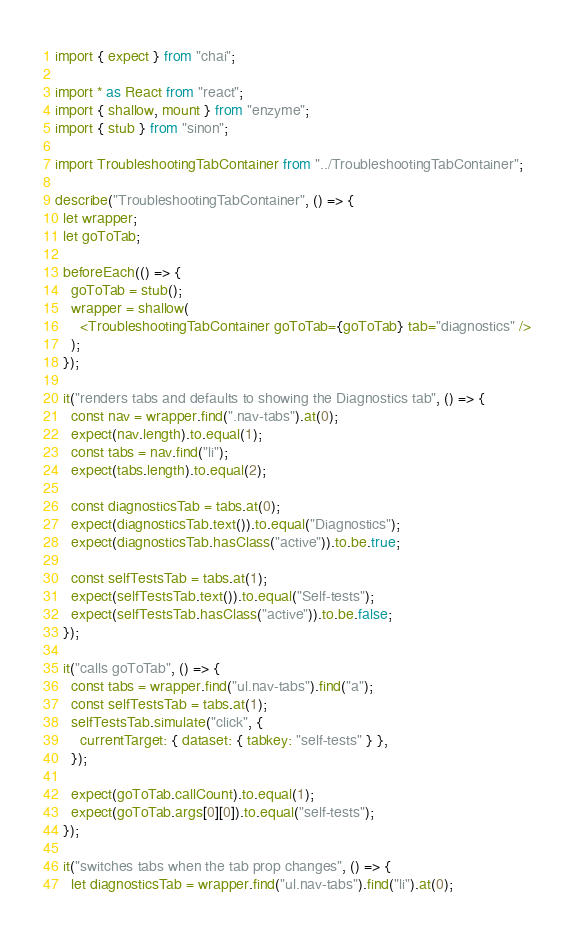<code> <loc_0><loc_0><loc_500><loc_500><_TypeScript_>import { expect } from "chai";

import * as React from "react";
import { shallow, mount } from "enzyme";
import { stub } from "sinon";

import TroubleshootingTabContainer from "../TroubleshootingTabContainer";

describe("TroubleshootingTabContainer", () => {
  let wrapper;
  let goToTab;

  beforeEach(() => {
    goToTab = stub();
    wrapper = shallow(
      <TroubleshootingTabContainer goToTab={goToTab} tab="diagnostics" />
    );
  });

  it("renders tabs and defaults to showing the Diagnostics tab", () => {
    const nav = wrapper.find(".nav-tabs").at(0);
    expect(nav.length).to.equal(1);
    const tabs = nav.find("li");
    expect(tabs.length).to.equal(2);

    const diagnosticsTab = tabs.at(0);
    expect(diagnosticsTab.text()).to.equal("Diagnostics");
    expect(diagnosticsTab.hasClass("active")).to.be.true;

    const selfTestsTab = tabs.at(1);
    expect(selfTestsTab.text()).to.equal("Self-tests");
    expect(selfTestsTab.hasClass("active")).to.be.false;
  });

  it("calls goToTab", () => {
    const tabs = wrapper.find("ul.nav-tabs").find("a");
    const selfTestsTab = tabs.at(1);
    selfTestsTab.simulate("click", {
      currentTarget: { dataset: { tabkey: "self-tests" } },
    });

    expect(goToTab.callCount).to.equal(1);
    expect(goToTab.args[0][0]).to.equal("self-tests");
  });

  it("switches tabs when the tab prop changes", () => {
    let diagnosticsTab = wrapper.find("ul.nav-tabs").find("li").at(0);</code> 